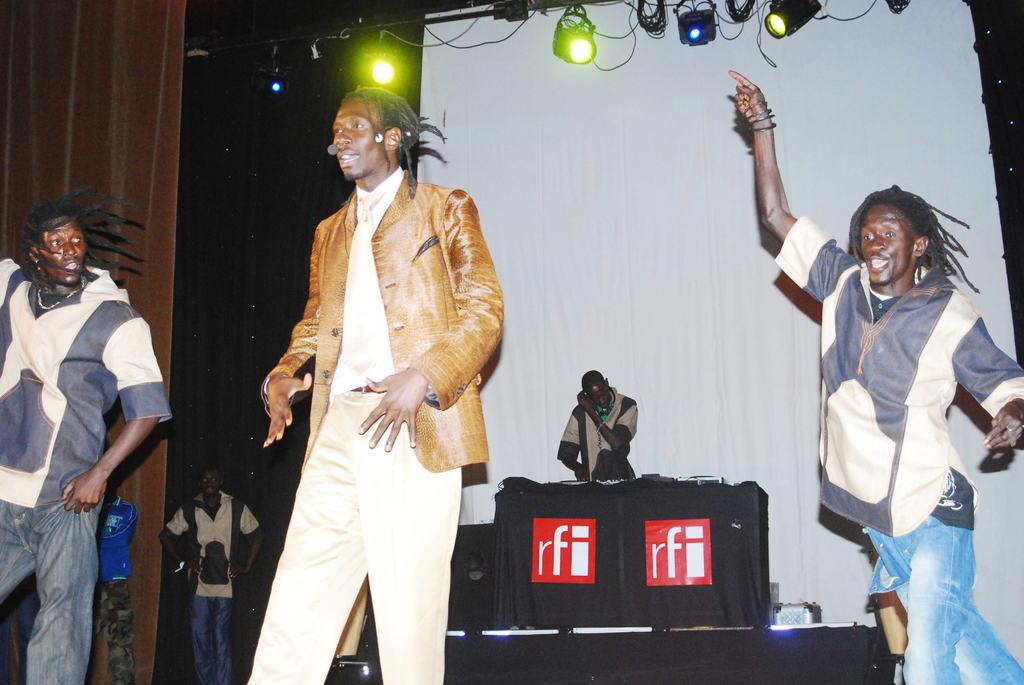Who or what is present in the image? There are people in the image. What can be seen in the background of the image? There is a table, curtains, lights, and other objects in the background of the image. Can you describe the table in the image? There is a table in the background of the image, and it has a cloth on it with other objects on top. What type of marble is being used in the playground depicted in the image? There is no playground or marble present in the image. 